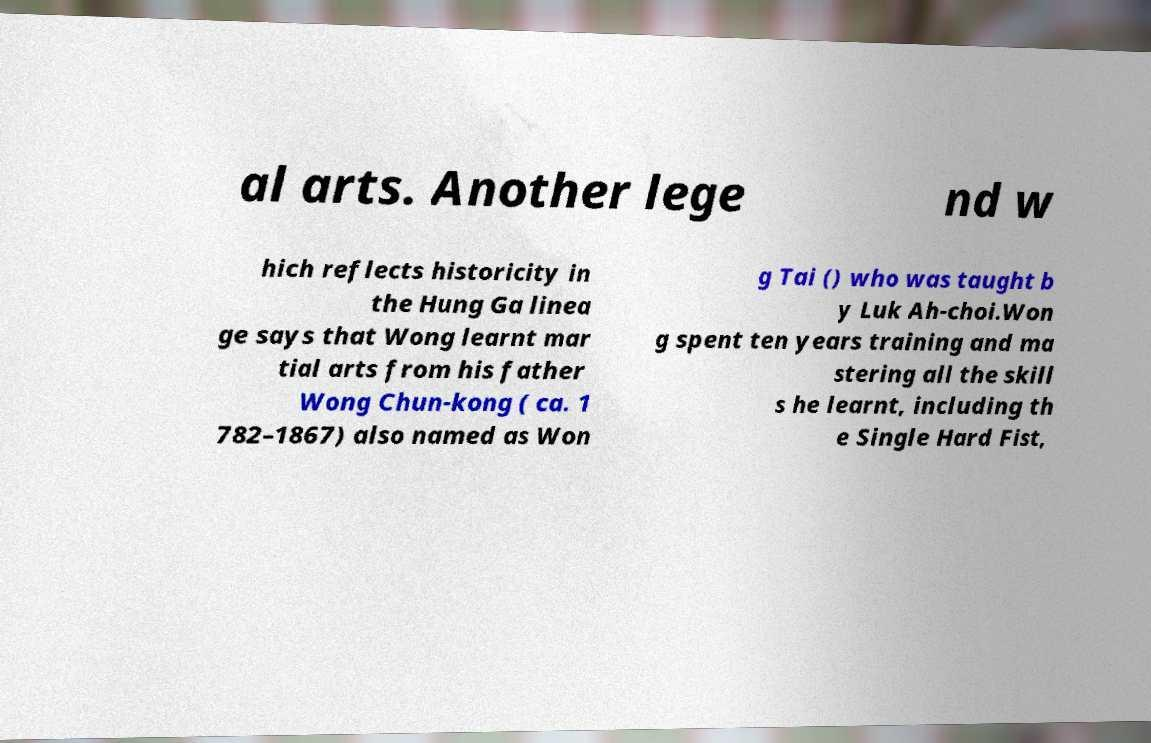I need the written content from this picture converted into text. Can you do that? al arts. Another lege nd w hich reflects historicity in the Hung Ga linea ge says that Wong learnt mar tial arts from his father Wong Chun-kong ( ca. 1 782–1867) also named as Won g Tai () who was taught b y Luk Ah-choi.Won g spent ten years training and ma stering all the skill s he learnt, including th e Single Hard Fist, 